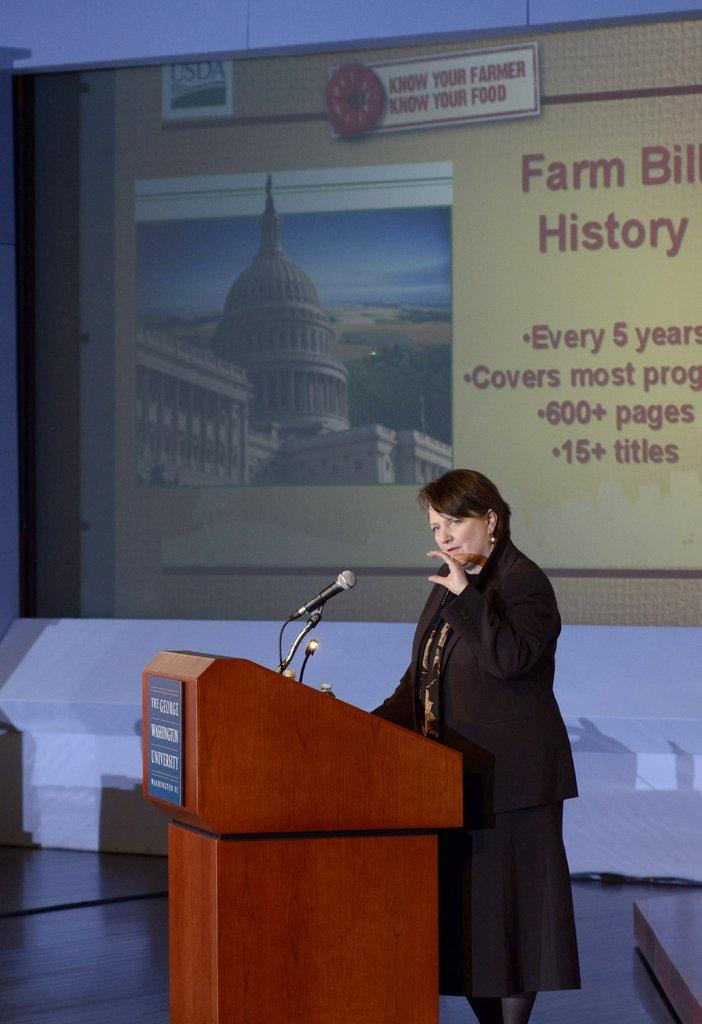Who is the main subject in the image? There is a woman in the image. What is the woman wearing? The woman is wearing a black suit. Where is the woman located in the image? The woman is standing at a speech desk. What is the woman doing at the speech desk? The woman is giving a speech. What can be seen in the background of the image? There is a projector screen in the background. How many sisters does the woman have, and are they present in the image? There is no information about the woman's sisters in the image, so we cannot determine their number or presence. What is the woman's tendency to wander in the wilderness, and is it relevant to the image? There is no information about the woman's tendency to wander in the wilderness, and it is not relevant to the image, which shows her giving a speech at a speech desk. 